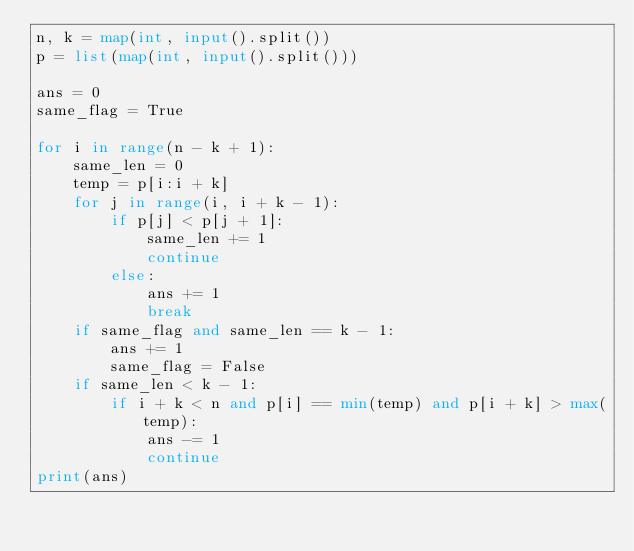<code> <loc_0><loc_0><loc_500><loc_500><_Python_>n, k = map(int, input().split())
p = list(map(int, input().split()))

ans = 0
same_flag = True

for i in range(n - k + 1):
    same_len = 0
    temp = p[i:i + k]
    for j in range(i, i + k - 1):
        if p[j] < p[j + 1]:
            same_len += 1
            continue
        else:
            ans += 1
            break
    if same_flag and same_len == k - 1:
        ans += 1
        same_flag = False
    if same_len < k - 1:
        if i + k < n and p[i] == min(temp) and p[i + k] > max(temp):
            ans -= 1
            continue
print(ans)
</code> 